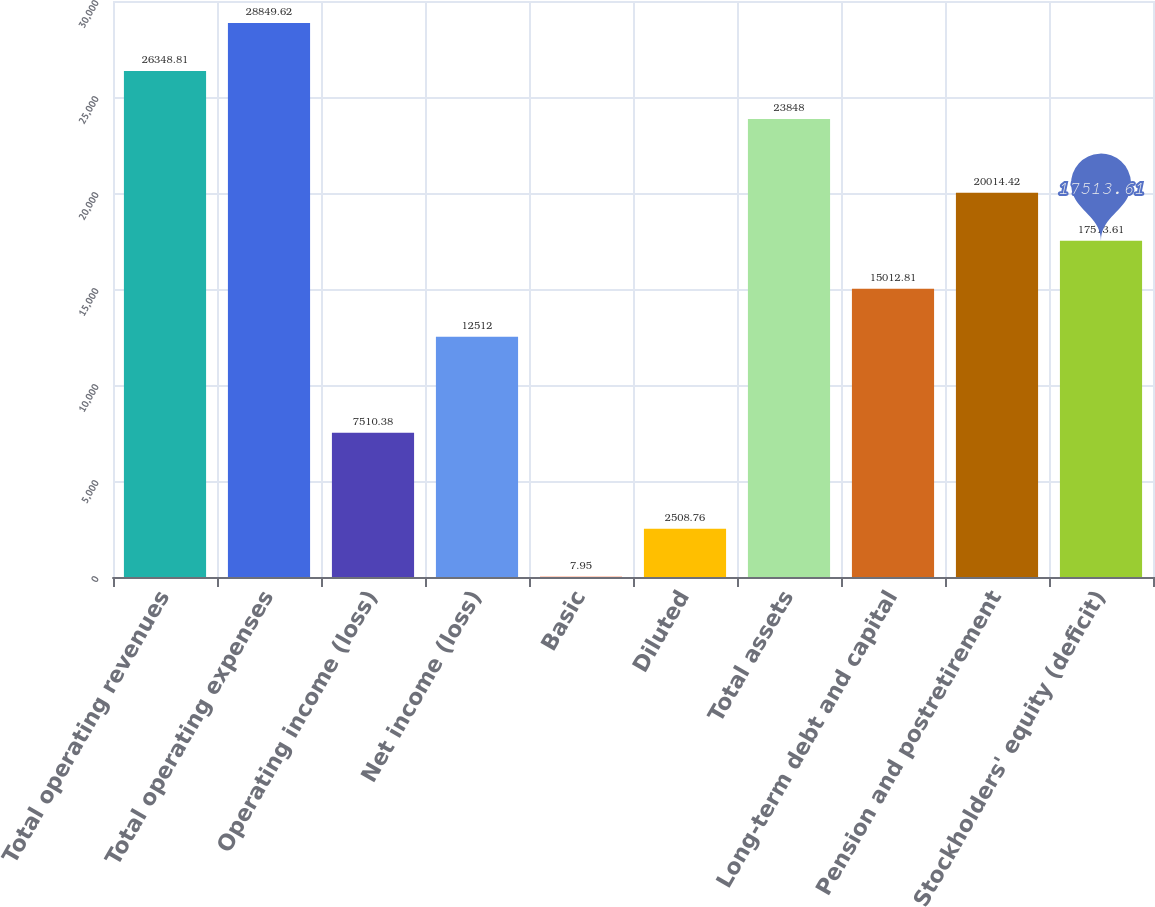Convert chart. <chart><loc_0><loc_0><loc_500><loc_500><bar_chart><fcel>Total operating revenues<fcel>Total operating expenses<fcel>Operating income (loss)<fcel>Net income (loss)<fcel>Basic<fcel>Diluted<fcel>Total assets<fcel>Long-term debt and capital<fcel>Pension and postretirement<fcel>Stockholders' equity (deficit)<nl><fcel>26348.8<fcel>28849.6<fcel>7510.38<fcel>12512<fcel>7.95<fcel>2508.76<fcel>23848<fcel>15012.8<fcel>20014.4<fcel>17513.6<nl></chart> 